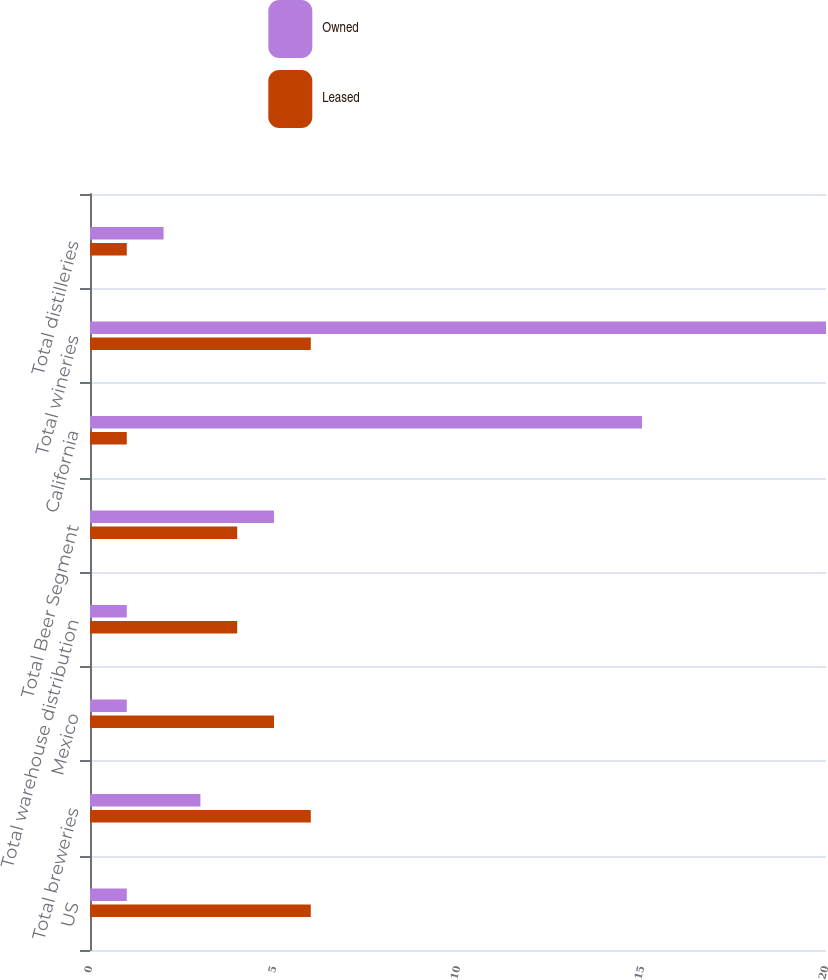<chart> <loc_0><loc_0><loc_500><loc_500><stacked_bar_chart><ecel><fcel>US<fcel>Total breweries<fcel>Mexico<fcel>Total warehouse distribution<fcel>Total Beer Segment<fcel>California<fcel>Total wineries<fcel>Total distilleries<nl><fcel>Owned<fcel>1<fcel>3<fcel>1<fcel>1<fcel>5<fcel>15<fcel>20<fcel>2<nl><fcel>Leased<fcel>6<fcel>6<fcel>5<fcel>4<fcel>4<fcel>1<fcel>6<fcel>1<nl></chart> 